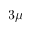Convert formula to latex. <formula><loc_0><loc_0><loc_500><loc_500>3 \mu</formula> 